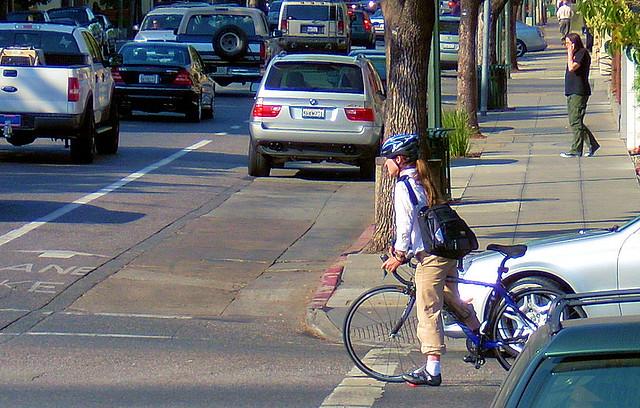How many persons can be seen in this picture?
Quick response, please. 3. Are there a lot of cars on the street?
Short answer required. Yes. What color is the child's bike?
Write a very short answer. Blue. 